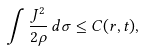Convert formula to latex. <formula><loc_0><loc_0><loc_500><loc_500>\int \frac { J ^ { 2 } } { 2 \rho } \, d \sigma \leq C ( { r } , t ) ,</formula> 